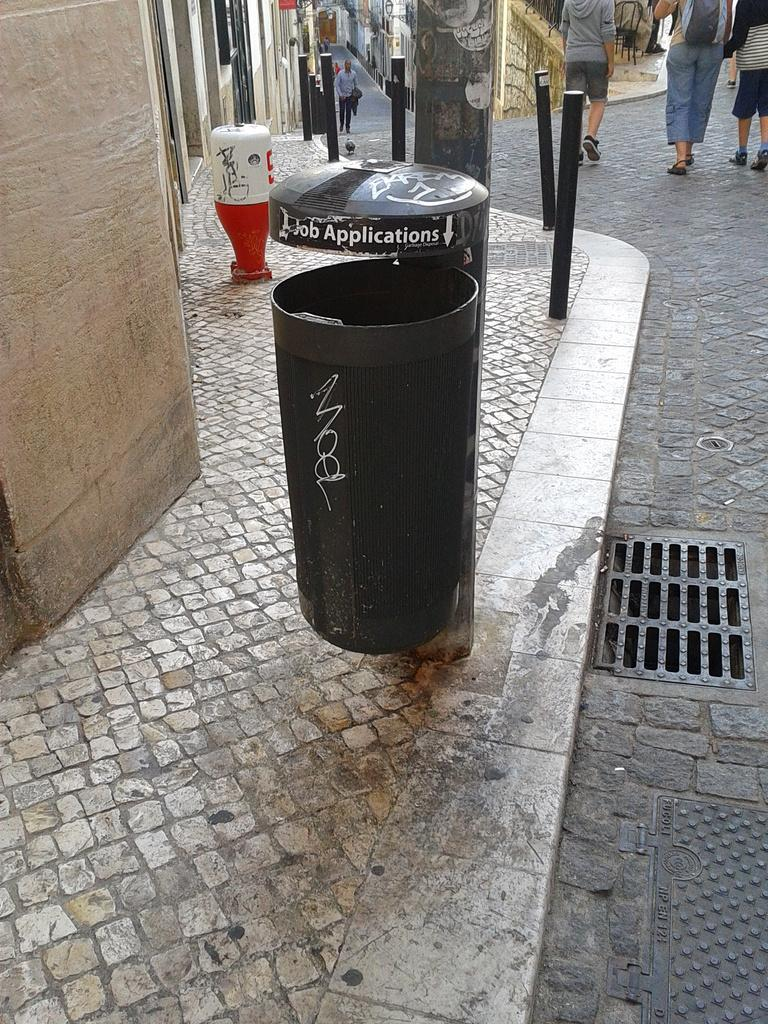<image>
Create a compact narrative representing the image presented. A can outside where people can toss their job applications. 